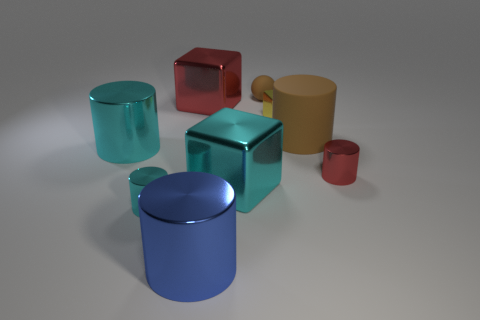Subtract all big blue cylinders. How many cylinders are left? 4 Subtract all cylinders. How many objects are left? 4 Subtract 1 cylinders. How many cylinders are left? 4 Subtract all brown cylinders. How many cylinders are left? 4 Subtract all yellow balls. How many green blocks are left? 0 Subtract all tiny brown shiny cylinders. Subtract all brown matte objects. How many objects are left? 7 Add 3 tiny rubber balls. How many tiny rubber balls are left? 4 Add 9 small brown balls. How many small brown balls exist? 10 Subtract 0 cyan balls. How many objects are left? 9 Subtract all purple cylinders. Subtract all red spheres. How many cylinders are left? 5 